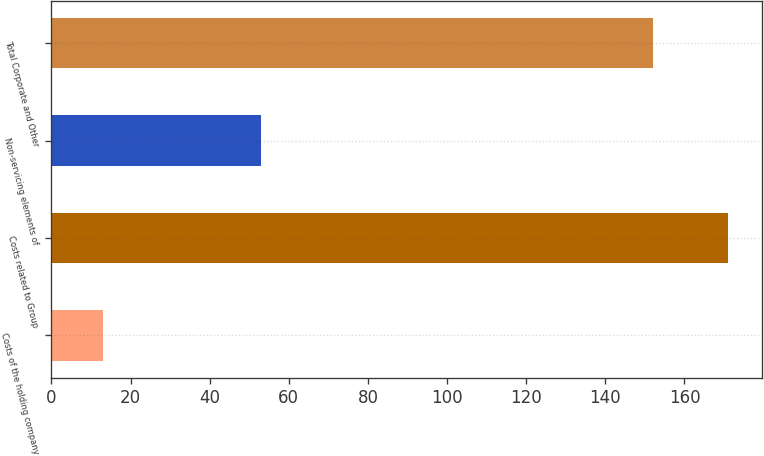<chart> <loc_0><loc_0><loc_500><loc_500><bar_chart><fcel>Costs of the holding company<fcel>Costs related to Group<fcel>Non-servicing elements of<fcel>Total Corporate and Other<nl><fcel>13<fcel>171<fcel>53<fcel>152<nl></chart> 